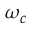Convert formula to latex. <formula><loc_0><loc_0><loc_500><loc_500>\omega _ { c }</formula> 